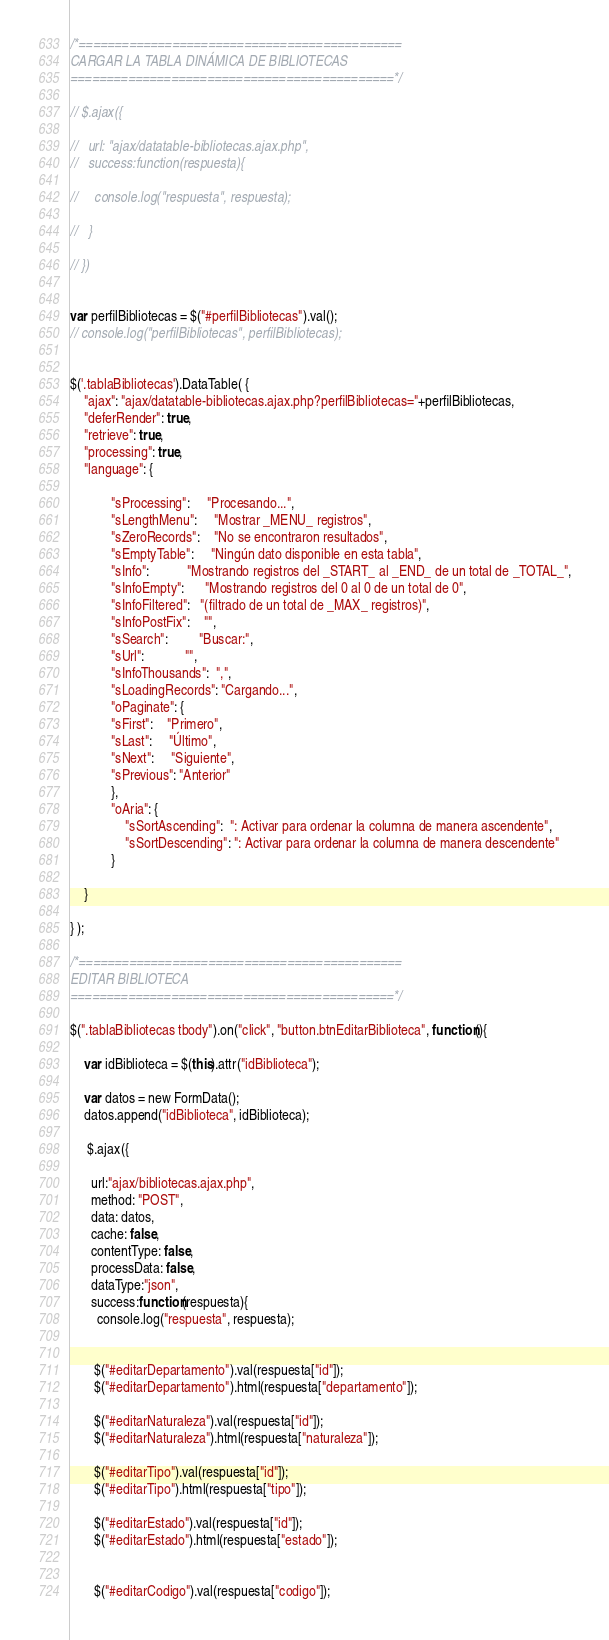Convert code to text. <code><loc_0><loc_0><loc_500><loc_500><_JavaScript_>/*=============================================
CARGAR LA TABLA DINÁMICA DE BIBLIOTECAS
=============================================*/

// $.ajax({

//   url: "ajax/datatable-bibliotecas.ajax.php",
//   success:function(respuesta){
    
//     console.log("respuesta", respuesta);

//   }

// })


var perfilBibliotecas = $("#perfilBibliotecas").val();
// console.log("perfilBibliotecas", perfilBibliotecas);


$('.tablaBibliotecas').DataTable( {
    "ajax": "ajax/datatable-bibliotecas.ajax.php?perfilBibliotecas="+perfilBibliotecas,
    "deferRender": true,
    "retrieve": true,
    "processing": true,
  	"language": {

			"sProcessing":     "Procesando...",
			"sLengthMenu":     "Mostrar _MENU_ registros",
			"sZeroRecords":    "No se encontraron resultados",
			"sEmptyTable":     "Ningún dato disponible en esta tabla",
			"sInfo":           "Mostrando registros del _START_ al _END_ de un total de _TOTAL_",
			"sInfoEmpty":      "Mostrando registros del 0 al 0 de un total de 0",
			"sInfoFiltered":   "(filtrado de un total de _MAX_ registros)",
			"sInfoPostFix":    "",
			"sSearch":         "Buscar:",
			"sUrl":            "",
			"sInfoThousands":  ",",
			"sLoadingRecords": "Cargando...",
			"oPaginate": {
			"sFirst":    "Primero",
			"sLast":     "Último",
			"sNext":     "Siguiente",
			"sPrevious": "Anterior"
			},
			"oAria": {
				"sSortAscending":  ": Activar para ordenar la columna de manera ascendente",
				"sSortDescending": ": Activar para ordenar la columna de manera descendente"
			}

	}

} );

/*=============================================
EDITAR BIBLIOTECA
=============================================*/

$(".tablaBibliotecas tbody").on("click", "button.btnEditarBiblioteca", function(){

	var idBiblioteca = $(this).attr("idBiblioteca");
	
	var datos = new FormData();
    datos.append("idBiblioteca", idBiblioteca);

     $.ajax({

      url:"ajax/bibliotecas.ajax.php",
      method: "POST",
      data: datos,
      cache: false,
      contentType: false,
      processData: false,
      dataType:"json",
      success:function(respuesta){
        console.log("respuesta", respuesta);
        

       $("#editarDepartamento").val(respuesta["id"]);
       $("#editarDepartamento").html(respuesta["departamento"]);

       $("#editarNaturaleza").val(respuesta["id"]);
       $("#editarNaturaleza").html(respuesta["naturaleza"]); 

       $("#editarTipo").val(respuesta["id"]);
       $("#editarTipo").html(respuesta["tipo"]); 

       $("#editarEstado").val(respuesta["id"]);
       $("#editarEstado").html(respuesta["estado"]); 


       $("#editarCodigo").val(respuesta["codigo"]);</code> 